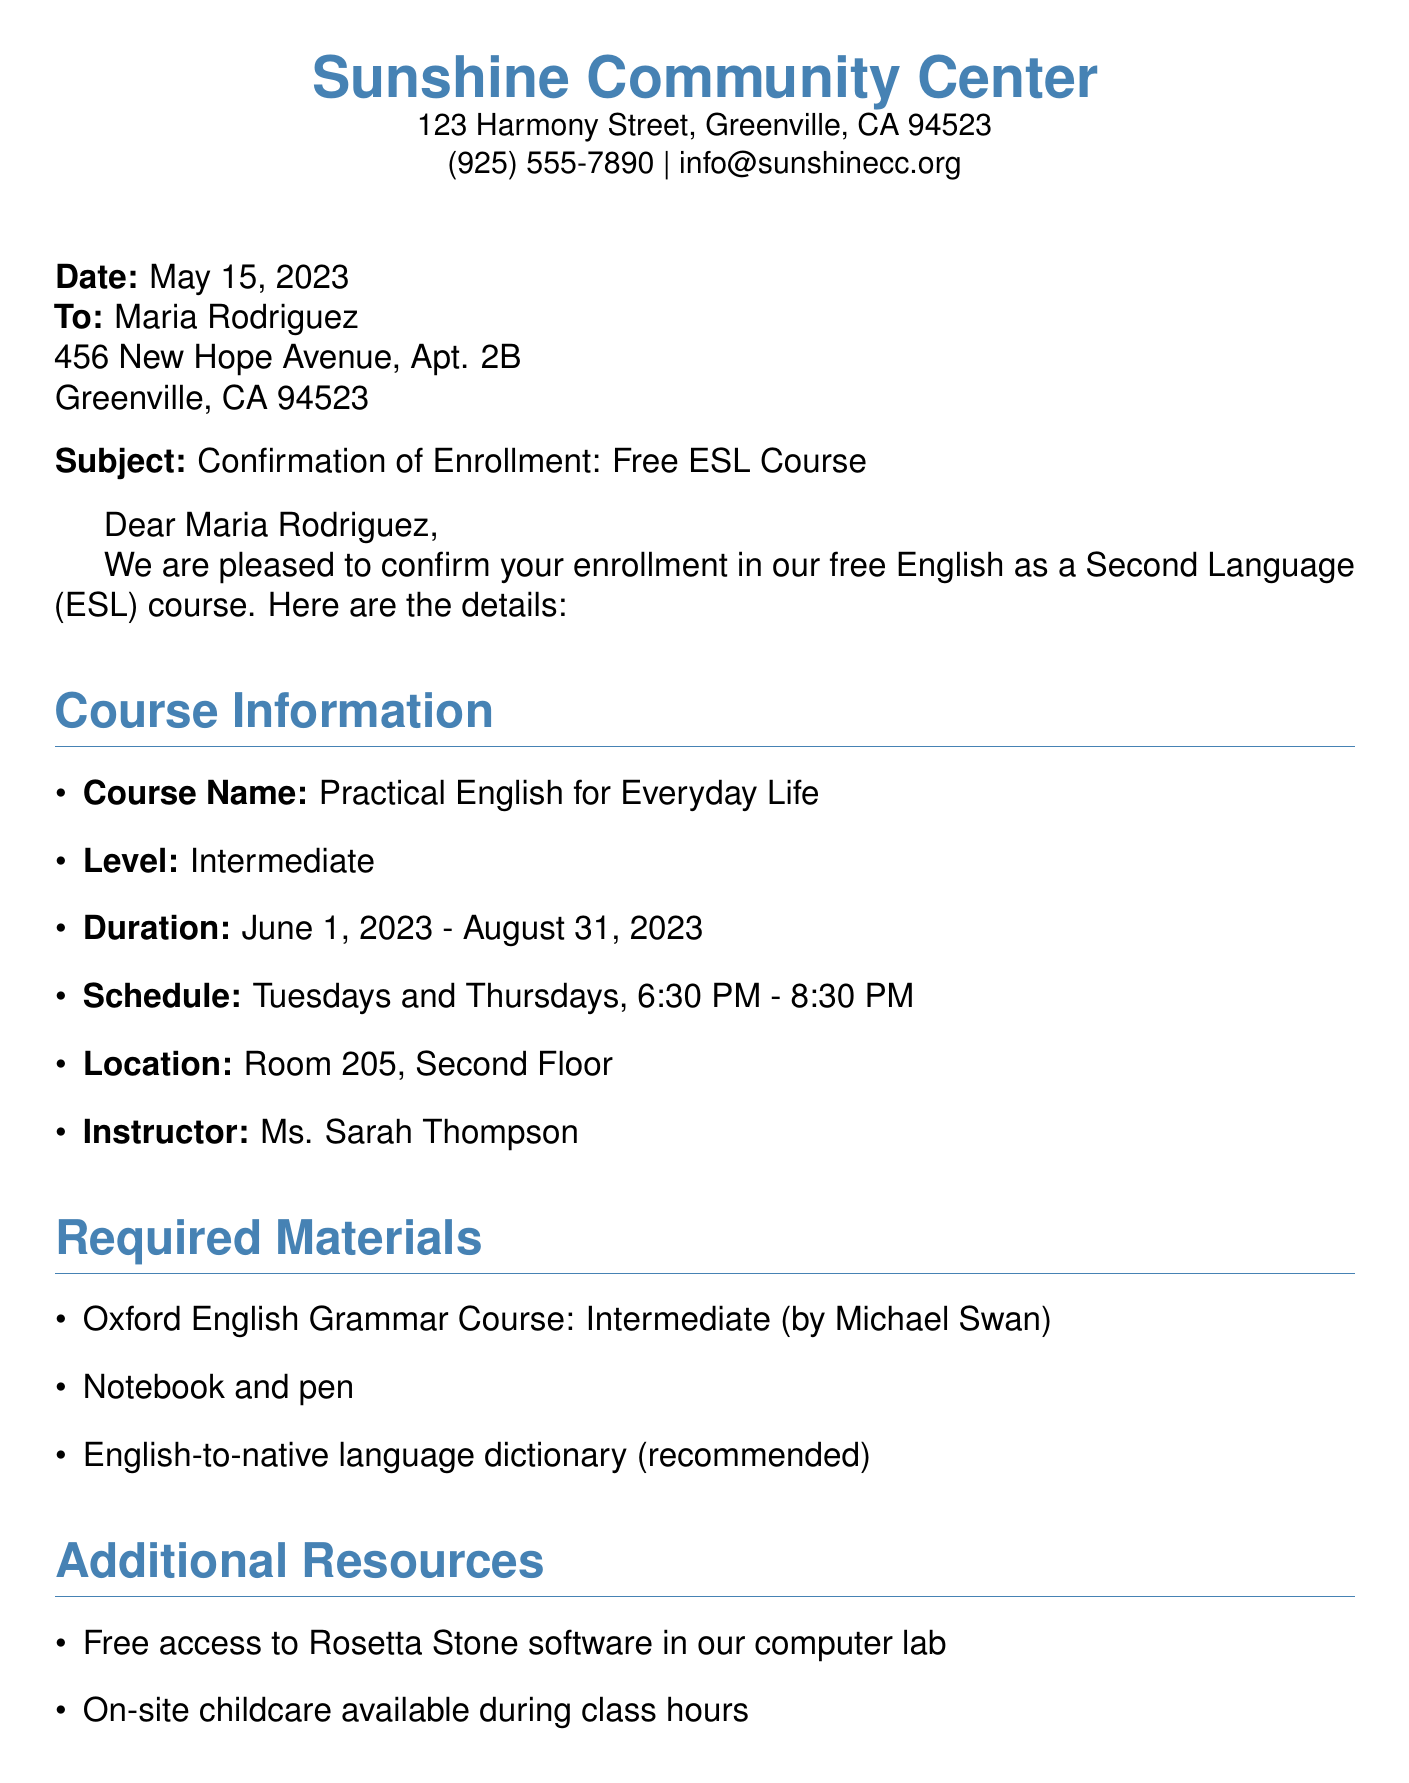What is the name of the course? The course name is clearly stated in the document under "Course Information."
Answer: Practical English for Everyday Life Who is the instructor of the course? The document lists the instructor in the "Course Information" section.
Answer: Ms. Sarah Thompson When does the course start? The start date is specified within the "Duration" section of the document.
Answer: June 1, 2023 How long is the course scheduled to run? The duration is mentioned in the "Duration" section, indicating the start and end dates.
Answer: June 1, 2023 - August 31, 2023 What are the class days? The class schedule is outlined under "Schedule" in the course details provided.
Answer: Tuesdays and Thursdays Is on-site childcare available? The document includes this information in the "Additional Resources" section.
Answer: Yes What materials are required for the course? The "Required Materials" section lists what students need for the class.
Answer: Oxford English Grammar Course: Intermediate (by Michael Swan), Notebook and pen, English-to-native language dictionary What time does the class start? The starting time is provided in the "Schedule" section of the course information.
Answer: 6:30 PM What is the fax transmission instruction? This information is included at the bottom of the document regarding the fax process.
Answer: This document was sent via fax 